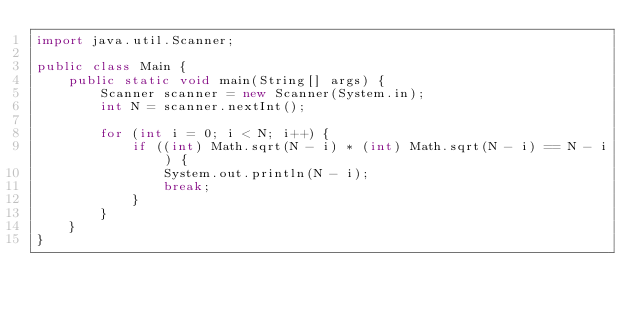Convert code to text. <code><loc_0><loc_0><loc_500><loc_500><_Java_>import java.util.Scanner;

public class Main {
    public static void main(String[] args) {
        Scanner scanner = new Scanner(System.in);
        int N = scanner.nextInt();

        for (int i = 0; i < N; i++) {
            if ((int) Math.sqrt(N - i) * (int) Math.sqrt(N - i) == N - i) {
                System.out.println(N - i);
                break;
            }
        }
    }
}</code> 